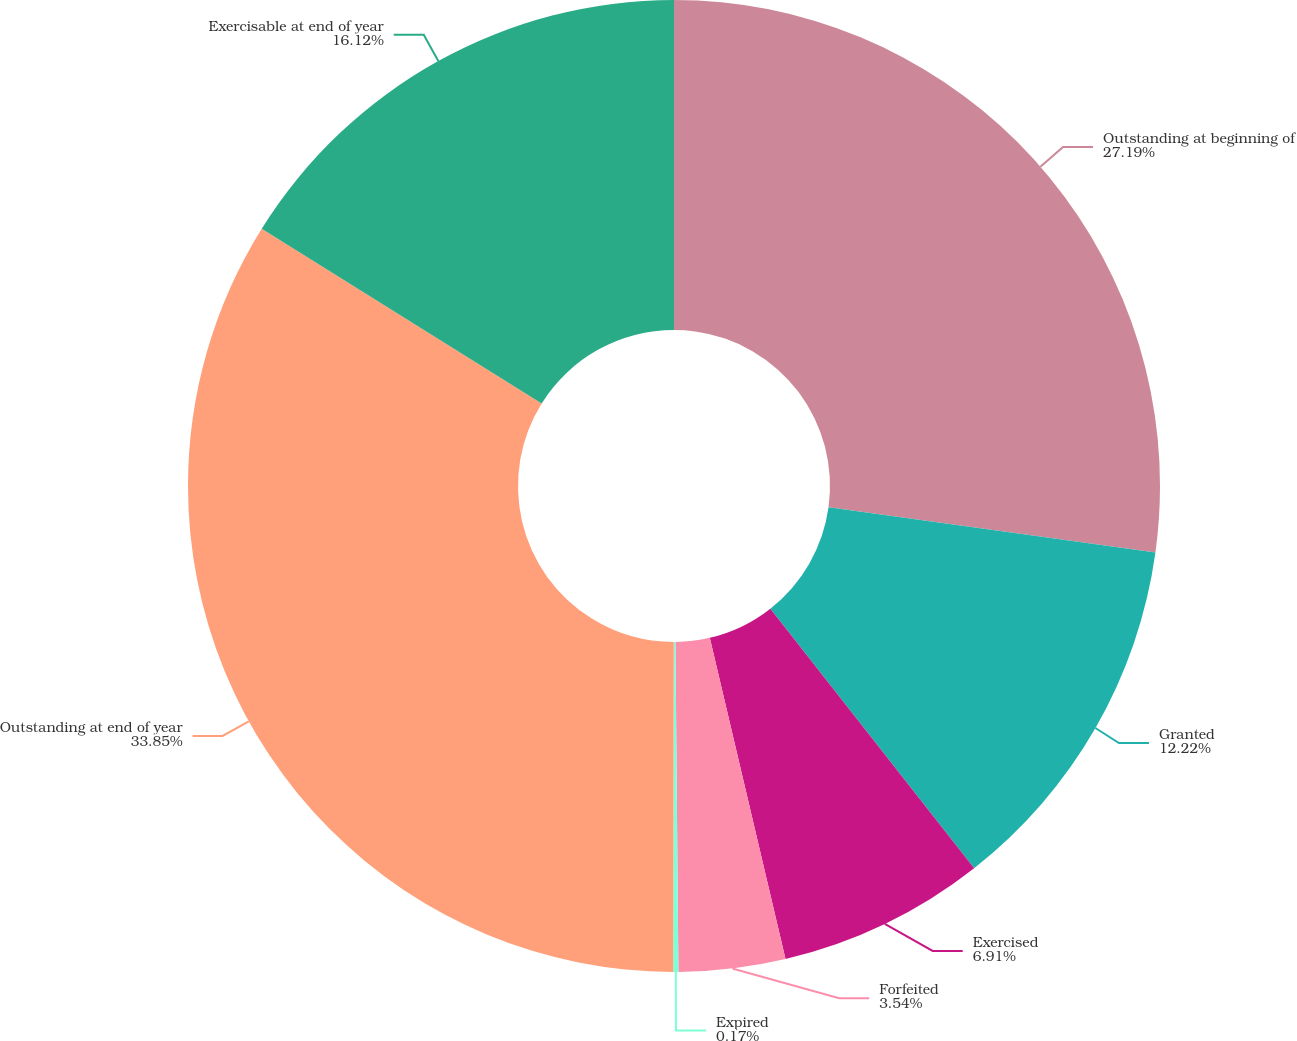Convert chart. <chart><loc_0><loc_0><loc_500><loc_500><pie_chart><fcel>Outstanding at beginning of<fcel>Granted<fcel>Exercised<fcel>Forfeited<fcel>Expired<fcel>Outstanding at end of year<fcel>Exercisable at end of year<nl><fcel>27.19%<fcel>12.22%<fcel>6.91%<fcel>3.54%<fcel>0.17%<fcel>33.86%<fcel>16.12%<nl></chart> 